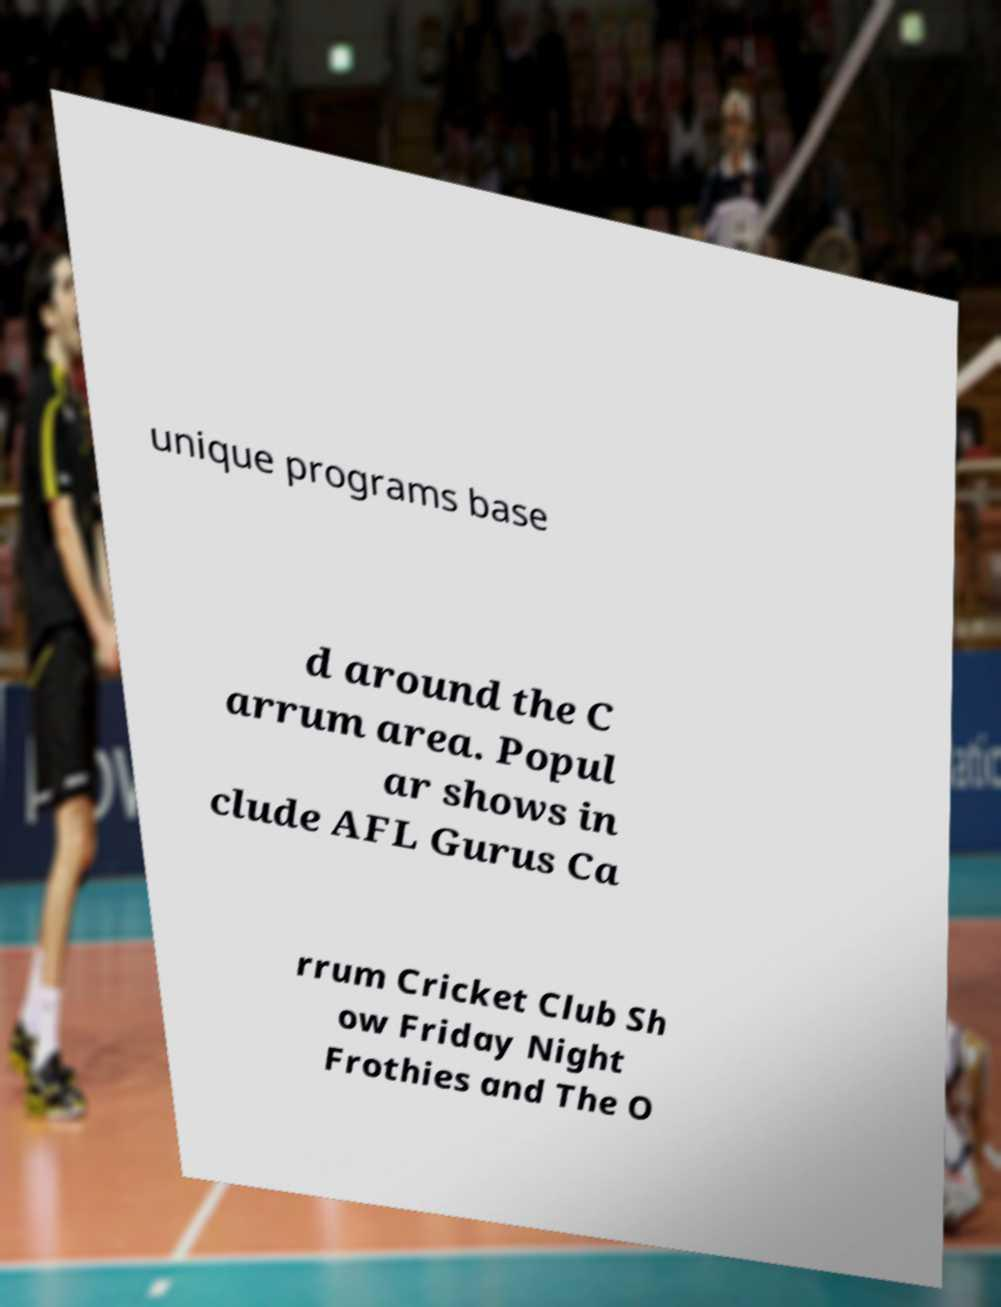What messages or text are displayed in this image? I need them in a readable, typed format. unique programs base d around the C arrum area. Popul ar shows in clude AFL Gurus Ca rrum Cricket Club Sh ow Friday Night Frothies and The O 